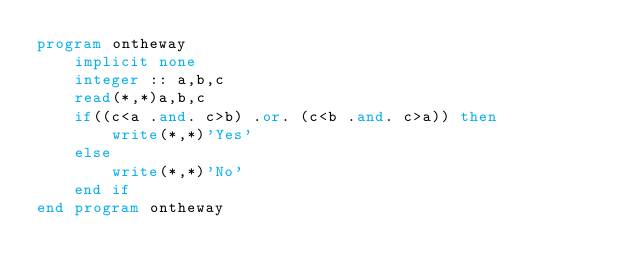<code> <loc_0><loc_0><loc_500><loc_500><_FORTRAN_>program ontheway
    implicit none
    integer :: a,b,c
    read(*,*)a,b,c
    if((c<a .and. c>b) .or. (c<b .and. c>a)) then
        write(*,*)'Yes'
    else
        write(*,*)'No'
    end if
end program ontheway</code> 